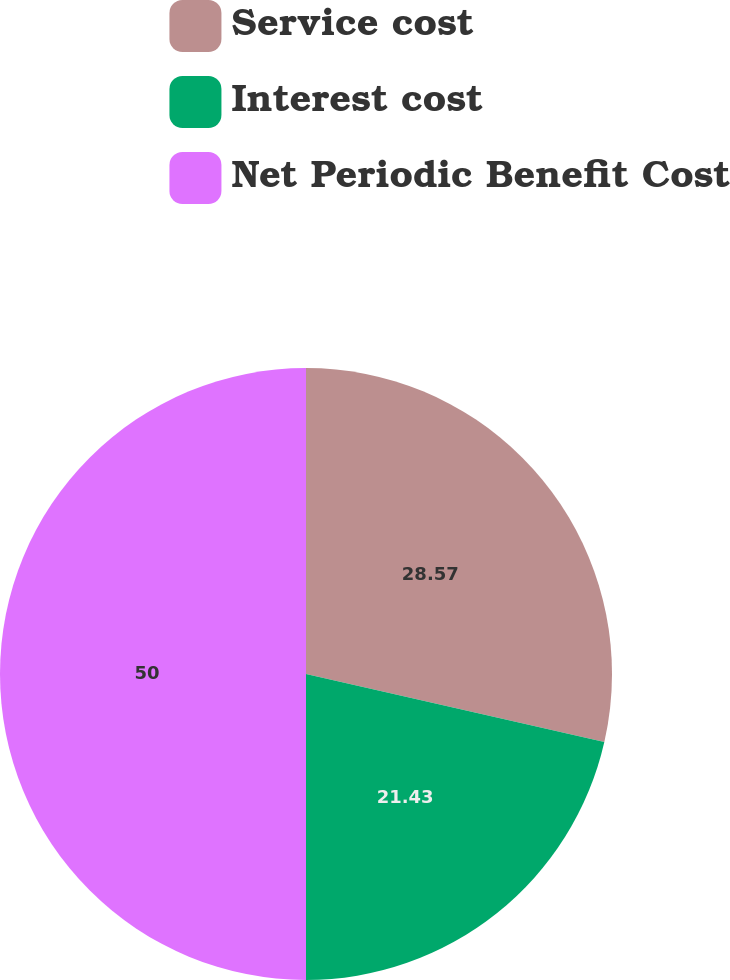<chart> <loc_0><loc_0><loc_500><loc_500><pie_chart><fcel>Service cost<fcel>Interest cost<fcel>Net Periodic Benefit Cost<nl><fcel>28.57%<fcel>21.43%<fcel>50.0%<nl></chart> 